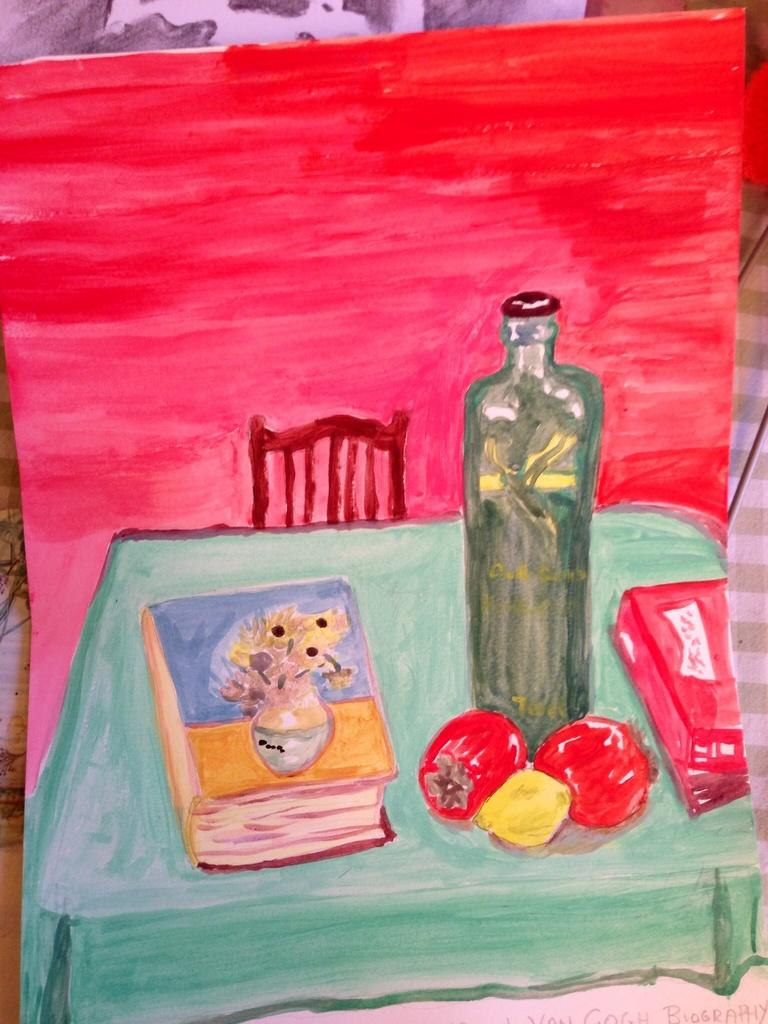What is depicted in the image? There is a painting in the image. What objects are included in the painting? The painting contains a chair, a table, a book, fruits, and a bottle. Can you describe the table setting in the painting? The table in the painting has a book, fruits, and a bottle on it. How many apples are balanced on the back of the chair in the painting? There are no apples or chairs visible in the painting; it only contains a table, a book, fruits, and a bottle. 